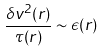Convert formula to latex. <formula><loc_0><loc_0><loc_500><loc_500>\frac { \delta v ^ { 2 } ( r ) } { \tau ( r ) } \sim \epsilon ( r )</formula> 